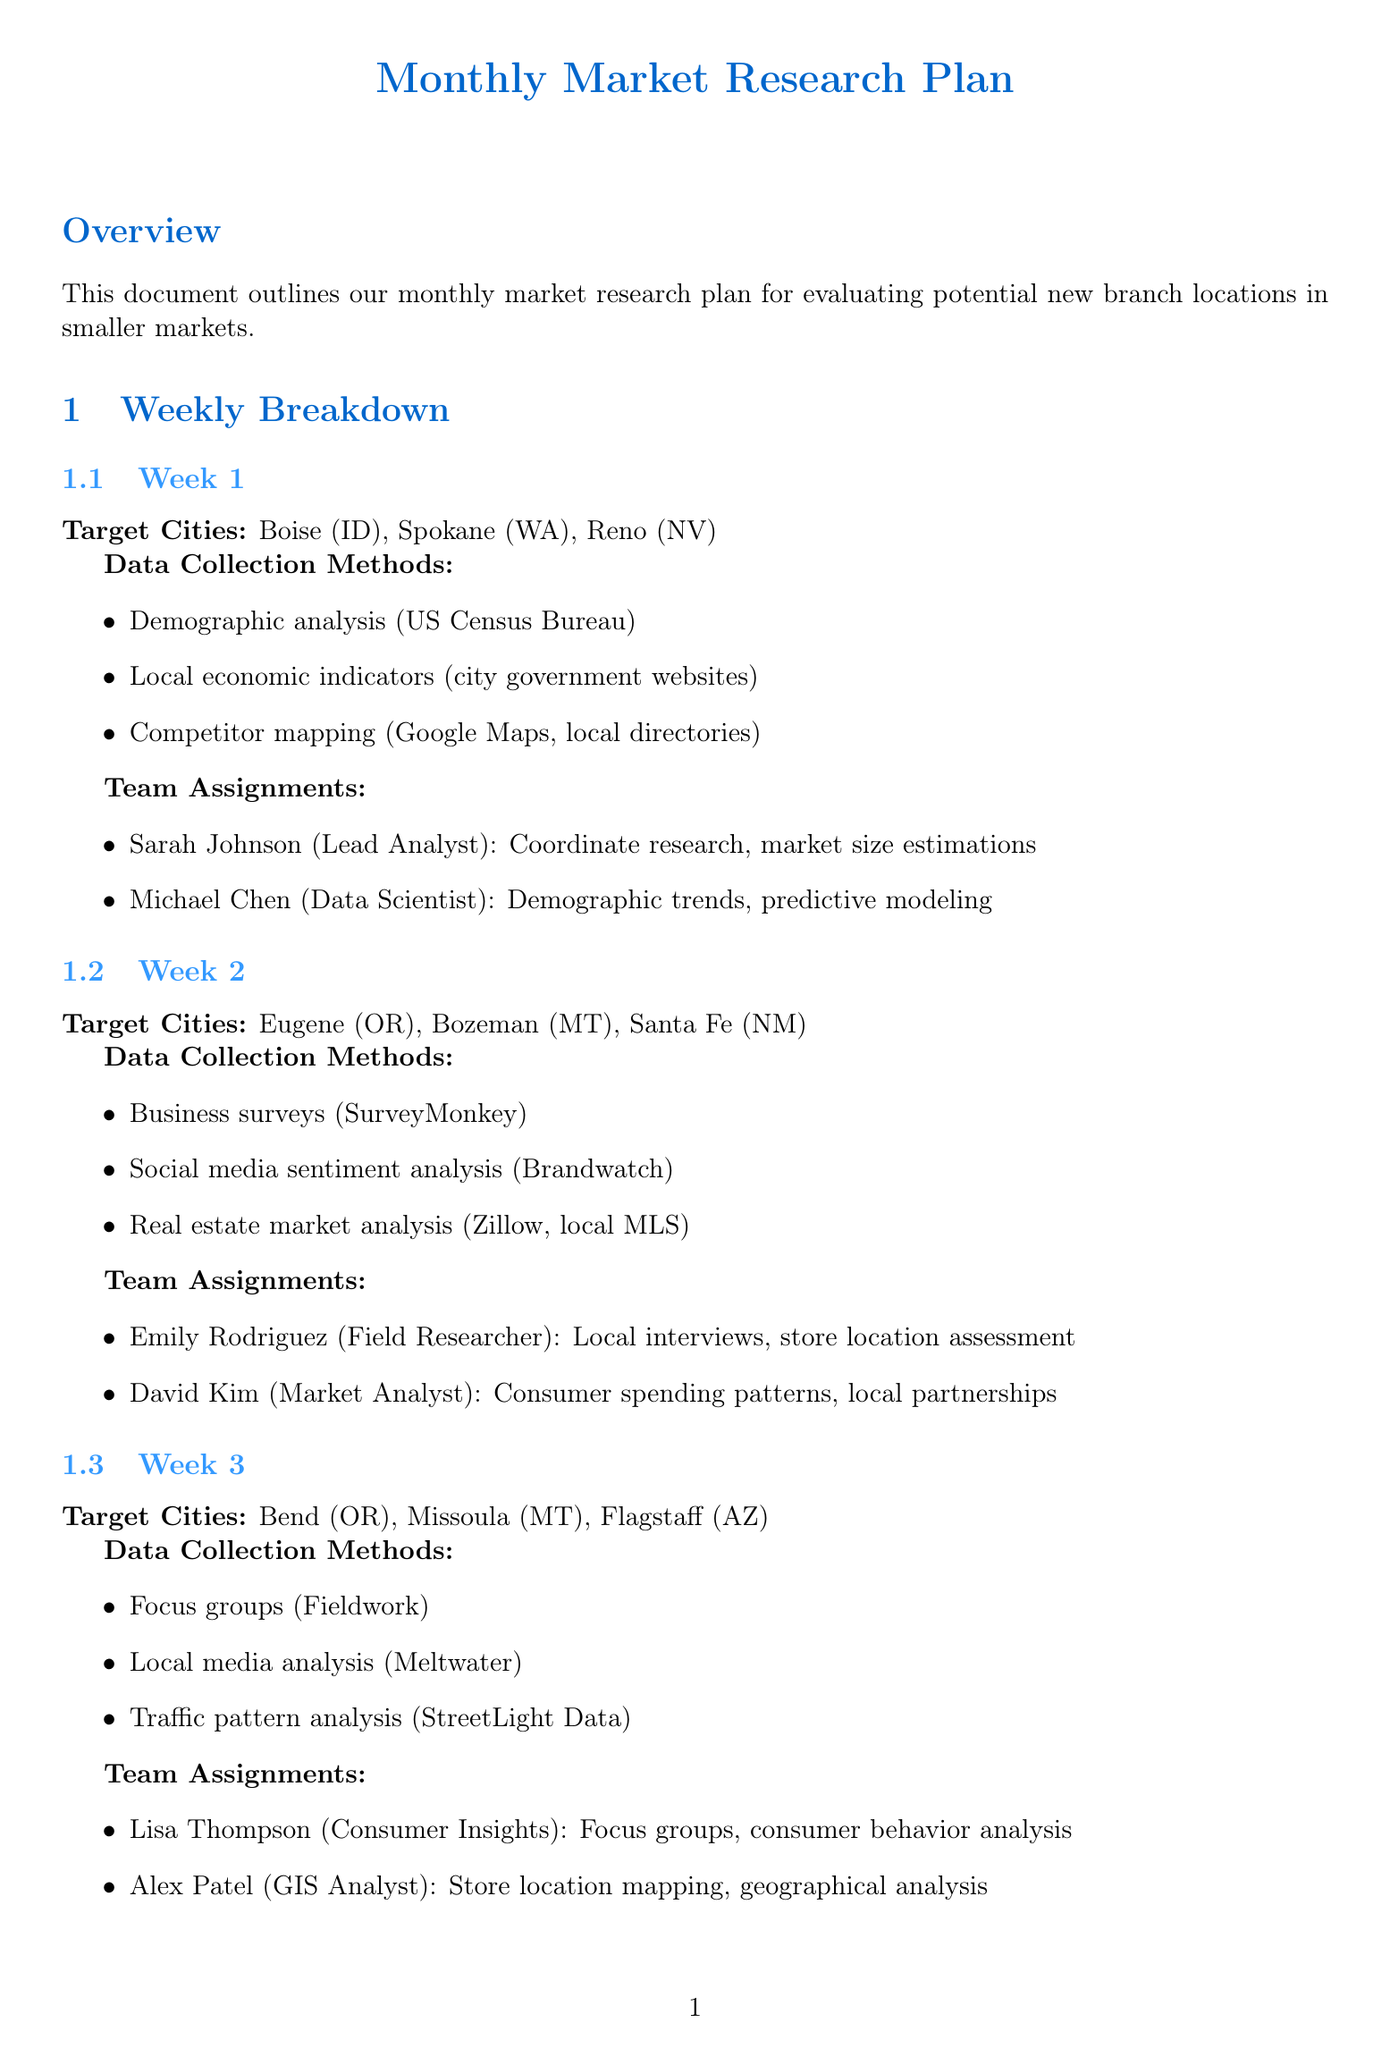What are the target cities for week 1? The document lists Boise, Spokane, and Reno as the target cities for week 1.
Answer: Boise, Spokane, Reno Who is the Lead Analyst for week 1? Sarah Johnson is assigned as the Lead Analyst in week 1.
Answer: Sarah Johnson What data collection method is used in week 2? Business surveys using SurveyMonkey are one of the methods listed for week 2.
Answer: Surveys distributed via SurveyMonkey Which tool is used for survey design and analysis? The document mentions Qualtrics as the tool for survey design and analysis.
Answer: Qualtrics What is the focus of week 3's consumer insights role? The Consumer Insights Specialist conducts focus group sessions and analyzes consumer behavior.
Answer: Focus groups, consumer behavior analysis How many cities are targeted in week 4? The document specifies three target cities for week 4.
Answer: Three What is one of the deliverables listed? The document includes a comprehensive market analysis report for each city as a deliverable.
Answer: Comprehensive market analysis report Which team member examines local zoning laws? Robert Martinez is designated as the team member reviewing local zoning laws and regulations.
Answer: Robert Martinez What type of questions are being analyzed in week 2? Local consumer spending patterns are analyzed as indicated for week 2.
Answer: Consumer spending patterns 